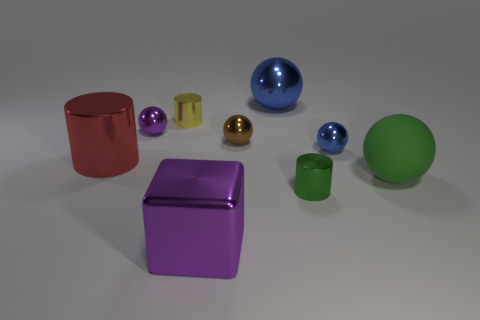Are there the same number of tiny brown balls behind the small green object and metallic blocks that are to the right of the red object?
Provide a succinct answer. Yes. What color is the large metallic cube?
Make the answer very short. Purple. How many objects are tiny yellow shiny cylinders to the left of the big blue sphere or tiny blue shiny balls?
Make the answer very short. 2. Does the purple object in front of the green matte thing have the same size as the cylinder to the right of the brown thing?
Make the answer very short. No. Is there any other thing that is the same material as the large green ball?
Ensure brevity in your answer.  No. How many things are either purple objects behind the big cylinder or objects that are behind the green cylinder?
Your response must be concise. 7. Do the big red thing and the blue ball that is on the left side of the green cylinder have the same material?
Offer a very short reply. Yes. There is a object that is both right of the tiny brown object and behind the tiny blue metal sphere; what shape is it?
Your answer should be very brief. Sphere. How many other objects are there of the same color as the large block?
Keep it short and to the point. 1. The small blue metallic thing is what shape?
Make the answer very short. Sphere. 